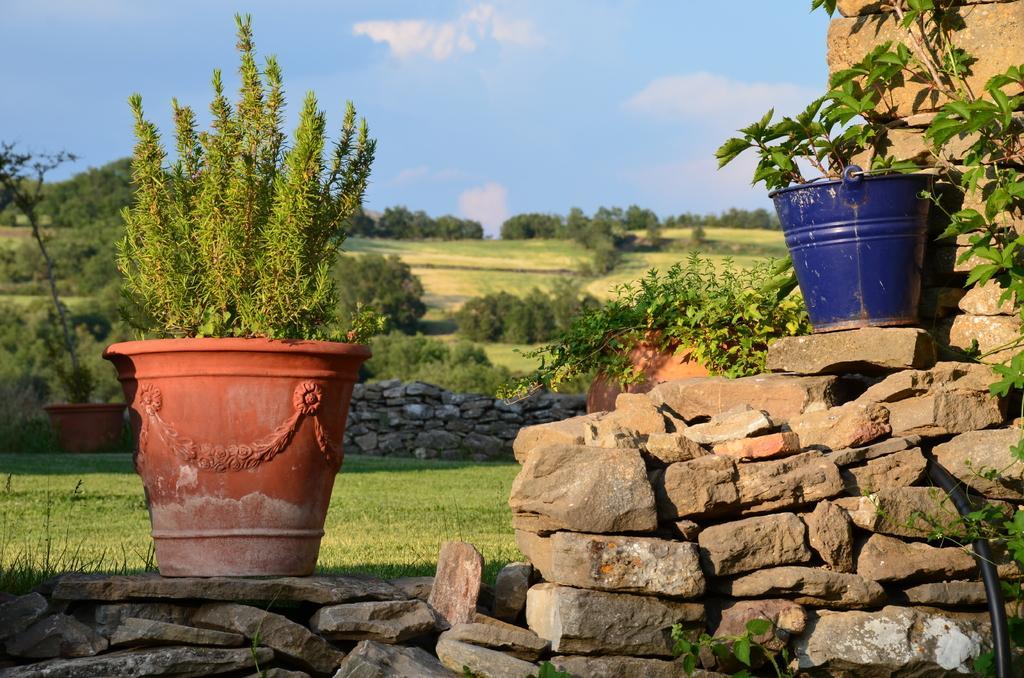In one or two sentences, can you explain what this image depicts? In the foreground of this image, there are stones on which few potted plants are on it. On the right side, there are plants and a black pipe. In the background, there is a tiny stone wall, a potted plant, trees, land, sky and the cloud. 